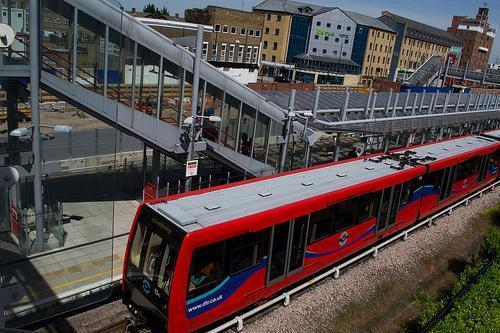How many trains are there?
Give a very brief answer. 1. 